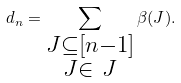<formula> <loc_0><loc_0><loc_500><loc_500>d _ { n } = \sum _ { \substack { J \subseteq [ n - 1 ] \\ J \in \ J } } \beta ( J ) .</formula> 